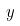<formula> <loc_0><loc_0><loc_500><loc_500>y</formula> 